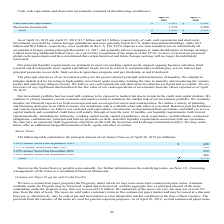According to Netapp's financial document, What were the short-term investments in 2018? According to the financial document, 2,450 (in millions). The relevant text states: "Short-term investments 1,574 2,450..." Also, How much cash, cash equivalents and short-term investments were held by various foreign subsidiaries in 2019? According to the financial document, $3.7 billion. The relevant text states: "As of April 26, 2019 and April 27, 2018, $3.7 billion and $4.5 billion, respectively, of cash, cash equivalents and short-term investments were held by va..." Also, What was the total cash, cash equivalents and short-term investments in 2019? According to the financial document, 3,899 (in millions). The relevant text states: "Total $ 3,899 $ 5,391..." Also, can you calculate: What was the change in short-term investments between 2018 and 2019? Based on the calculation: 1,574-2,450, the result is -876 (in millions). This is based on the information: "Short-term investments 1,574 2,450 Short-term investments 1,574 2,450..." The key data points involved are: 1,574, 2,450. Also, How many years did the total of cash and cash equivalents and short-term investments exceed $4,000 million? Based on the analysis, there are 1 instances. The counting process: 2018. Also, can you calculate: What was the percentage change in cash and cash equivalents between 2018 and 2019? To answer this question, I need to perform calculations using the financial data. The calculation is: (2,325-2,941)/2,941, which equals -20.95 (percentage). This is based on the information: "Cash and cash equivalents $ 2,325 $ 2,941 Cash and cash equivalents $ 2,325 $ 2,941..." The key data points involved are: 2,325, 2,941. 